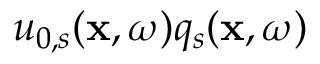Convert formula to latex. <formula><loc_0><loc_0><loc_500><loc_500>u _ { 0 , s } ( x , \omega ) q _ { s } ( x , \omega )</formula> 